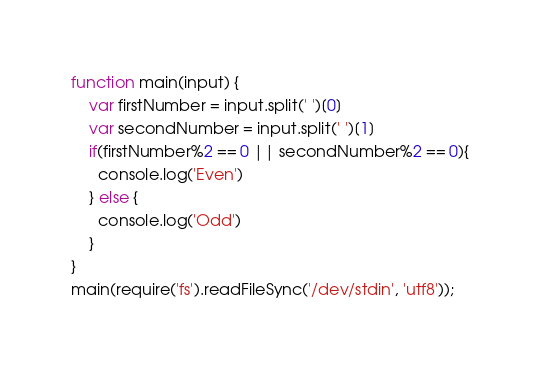<code> <loc_0><loc_0><loc_500><loc_500><_JavaScript_>function main(input) {
  	var firstNumber = input.split(' ')[0]
    var secondNumber = input.split(' ')[1]
    if(firstNumber%2 == 0 || secondNumber%2 == 0){
      console.log('Even')
    } else {
      console.log('Odd')
    }
}
main(require('fs').readFileSync('/dev/stdin', 'utf8'));</code> 